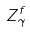<formula> <loc_0><loc_0><loc_500><loc_500>Z _ { \gamma } ^ { f }</formula> 